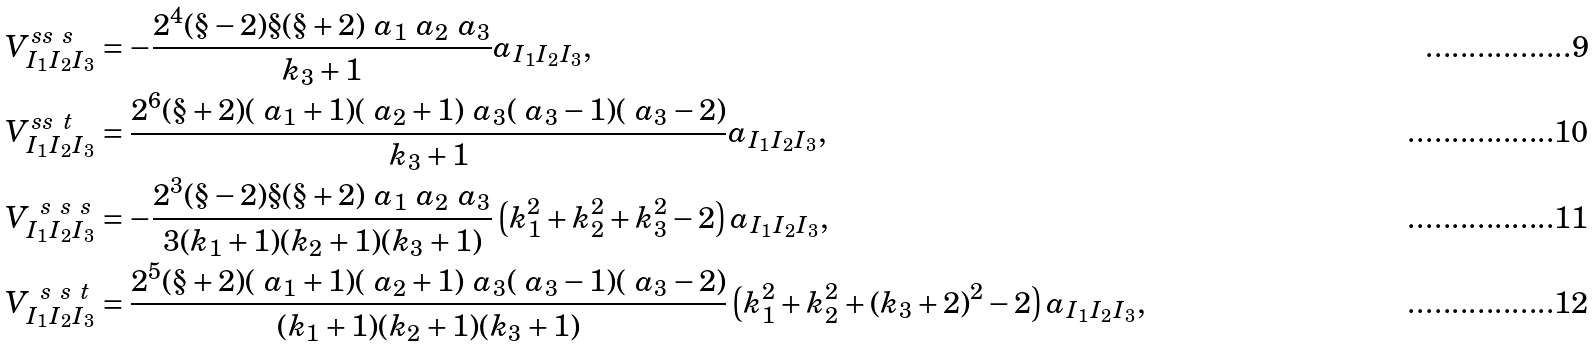<formula> <loc_0><loc_0><loc_500><loc_500>V ^ { s s \ s } _ { I _ { 1 } I _ { 2 } I _ { 3 } } & = - \frac { 2 ^ { 4 } ( \S - 2 ) \S ( \S + 2 ) \ a _ { 1 } \ a _ { 2 } \ a _ { 3 } } { k _ { 3 } + 1 } a _ { I _ { 1 } I _ { 2 } I _ { 3 } } , \\ V ^ { s s \ t } _ { I _ { 1 } I _ { 2 } I _ { 3 } } & = \frac { 2 ^ { 6 } ( \S + 2 ) ( \ a _ { 1 } + 1 ) ( \ a _ { 2 } + 1 ) \ a _ { 3 } ( \ a _ { 3 } - 1 ) ( \ a _ { 3 } - 2 ) } { k _ { 3 } + 1 } a _ { I _ { 1 } I _ { 2 } I _ { 3 } } , \\ V ^ { \ s \ s \ s } _ { I _ { 1 } I _ { 2 } I _ { 3 } } & = - \frac { 2 ^ { 3 } ( \S - 2 ) \S ( \S + 2 ) \ a _ { 1 } \ a _ { 2 } \ a _ { 3 } } { 3 ( k _ { 1 } + 1 ) ( k _ { 2 } + 1 ) ( k _ { 3 } + 1 ) } \left ( k _ { 1 } ^ { 2 } + k _ { 2 } ^ { 2 } + k _ { 3 } ^ { 2 } - 2 \right ) a _ { I _ { 1 } I _ { 2 } I _ { 3 } } , \\ V ^ { \ s \ s \ t } _ { I _ { 1 } I _ { 2 } I _ { 3 } } & = \frac { 2 ^ { 5 } ( \S + 2 ) ( \ a _ { 1 } + 1 ) ( \ a _ { 2 } + 1 ) \ a _ { 3 } ( \ a _ { 3 } - 1 ) ( \ a _ { 3 } - 2 ) } { ( k _ { 1 } + 1 ) ( k _ { 2 } + 1 ) ( k _ { 3 } + 1 ) } \left ( k _ { 1 } ^ { 2 } + k _ { 2 } ^ { 2 } + ( k _ { 3 } + 2 ) ^ { 2 } - 2 \right ) a _ { I _ { 1 } I _ { 2 } I _ { 3 } } ,</formula> 